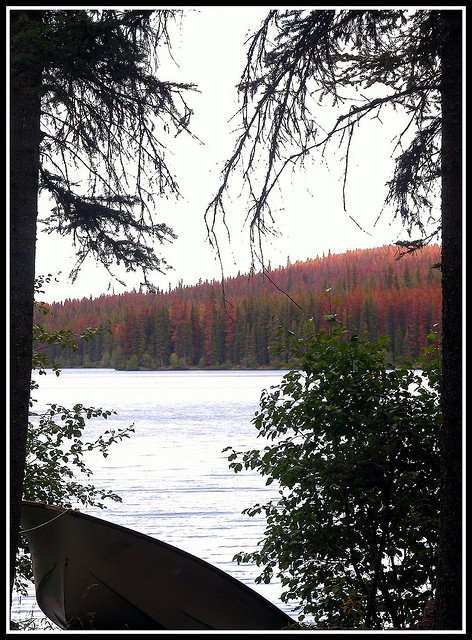Describe the objects in this image and their specific colors. I can see a boat in black, gray, and white tones in this image. 